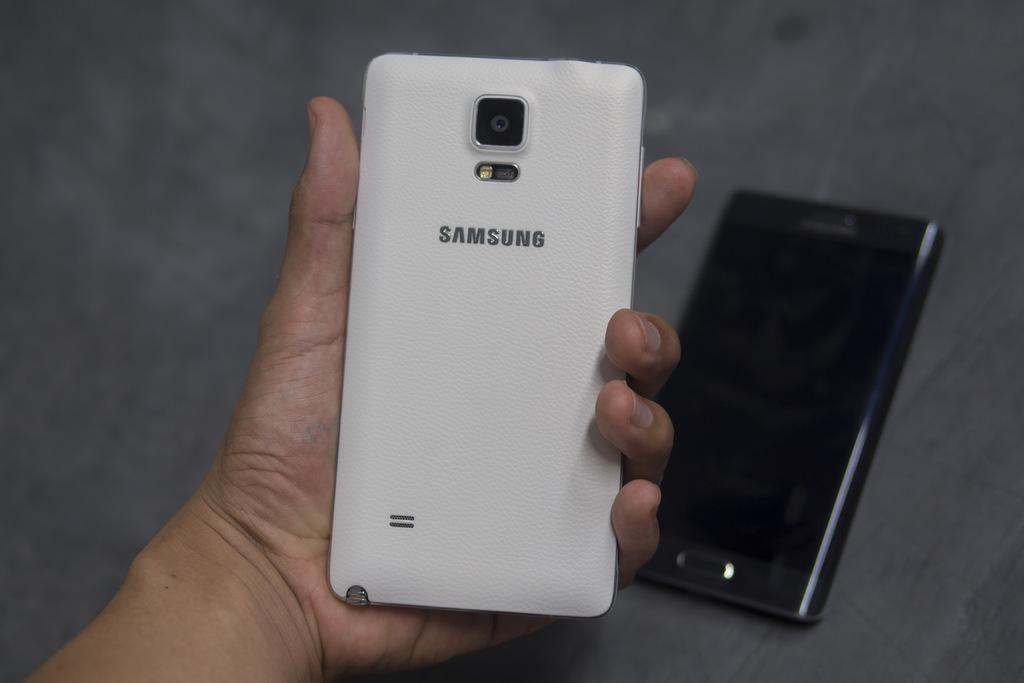<image>
Share a concise interpretation of the image provided. A person is holding a Samsung phone in their left hand. 